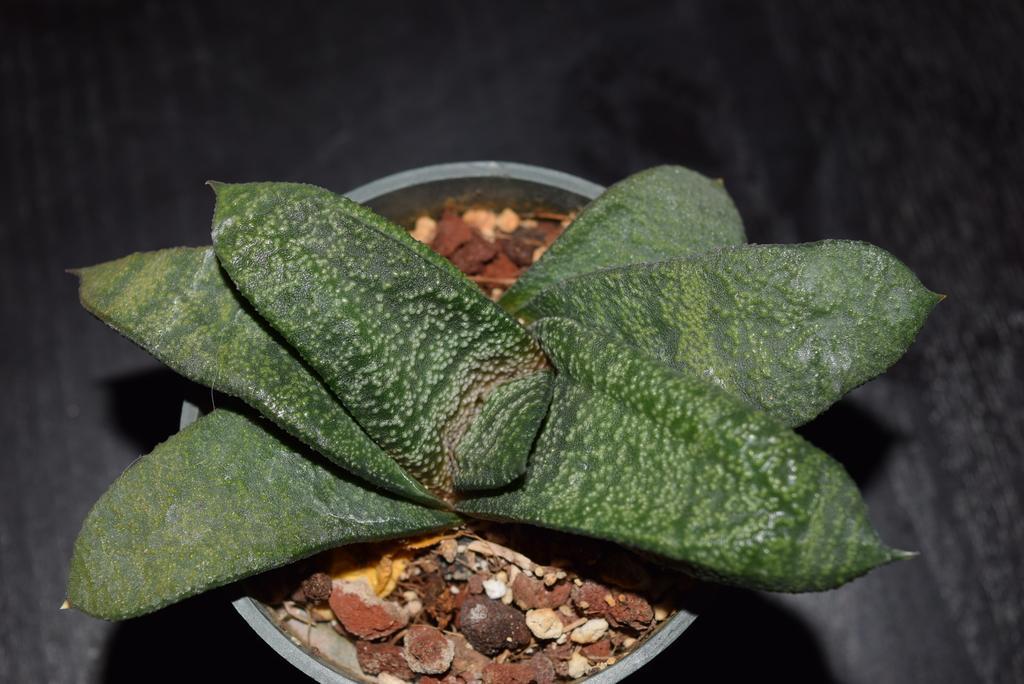How would you summarize this image in a sentence or two? Here there is a plant, where there is black color back ground. 